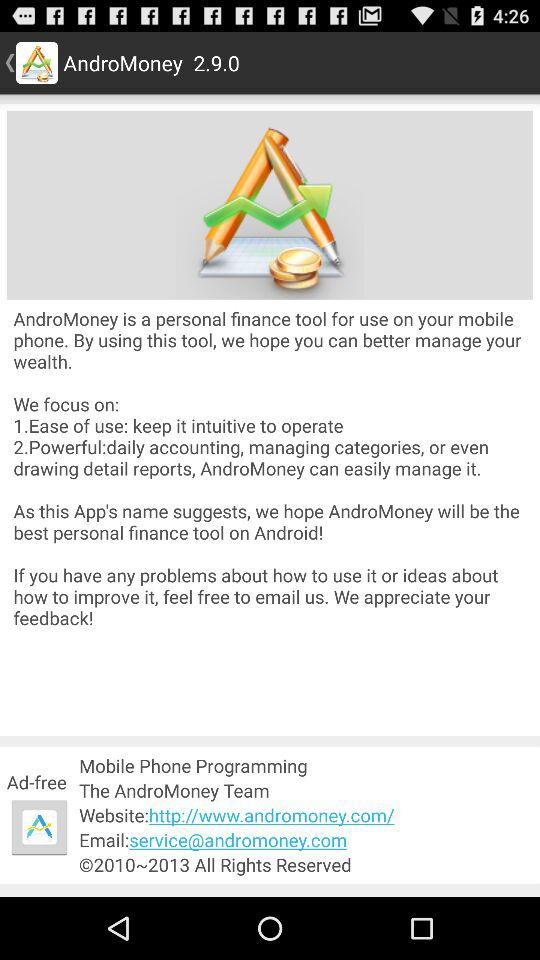What is the application name? The application name is "AndroMoney". 